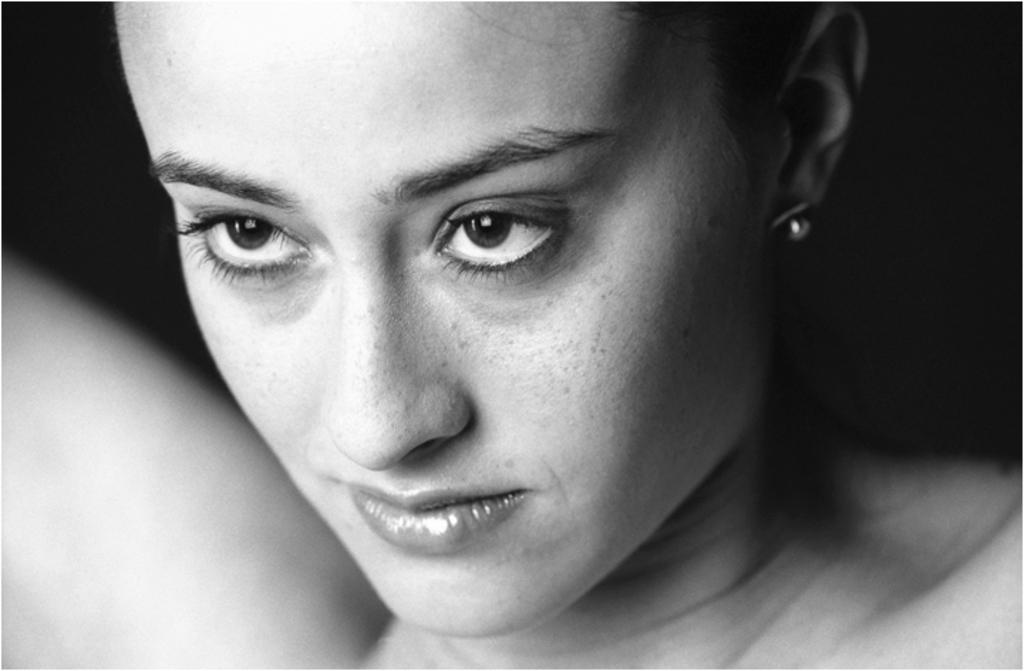Who is the main subject in the image? There is a woman in the image. What can be said about the background of the image? The background of the image is dark. How would you describe the color scheme of the image? The image is black and white. What type of string is being used by the woman in the image? There is no string present in the image, and the woman is not using any string. 